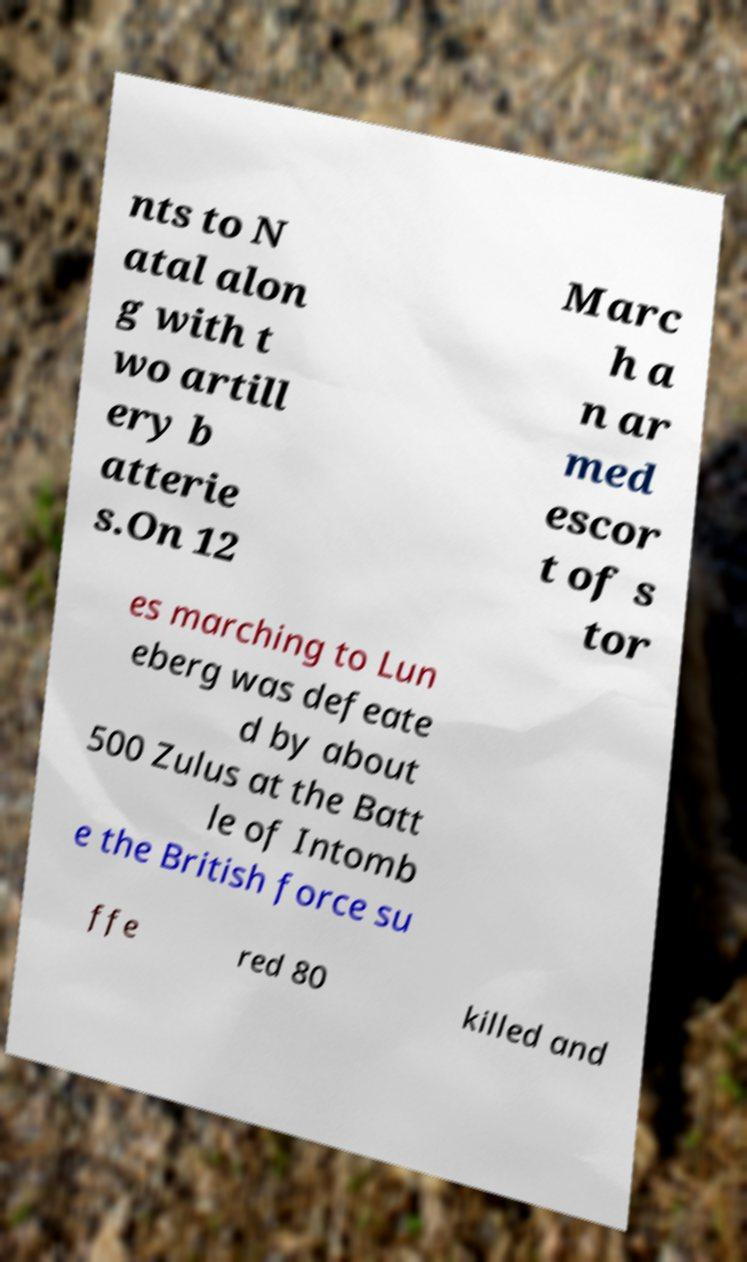Can you read and provide the text displayed in the image?This photo seems to have some interesting text. Can you extract and type it out for me? nts to N atal alon g with t wo artill ery b atterie s.On 12 Marc h a n ar med escor t of s tor es marching to Lun eberg was defeate d by about 500 Zulus at the Batt le of Intomb e the British force su ffe red 80 killed and 